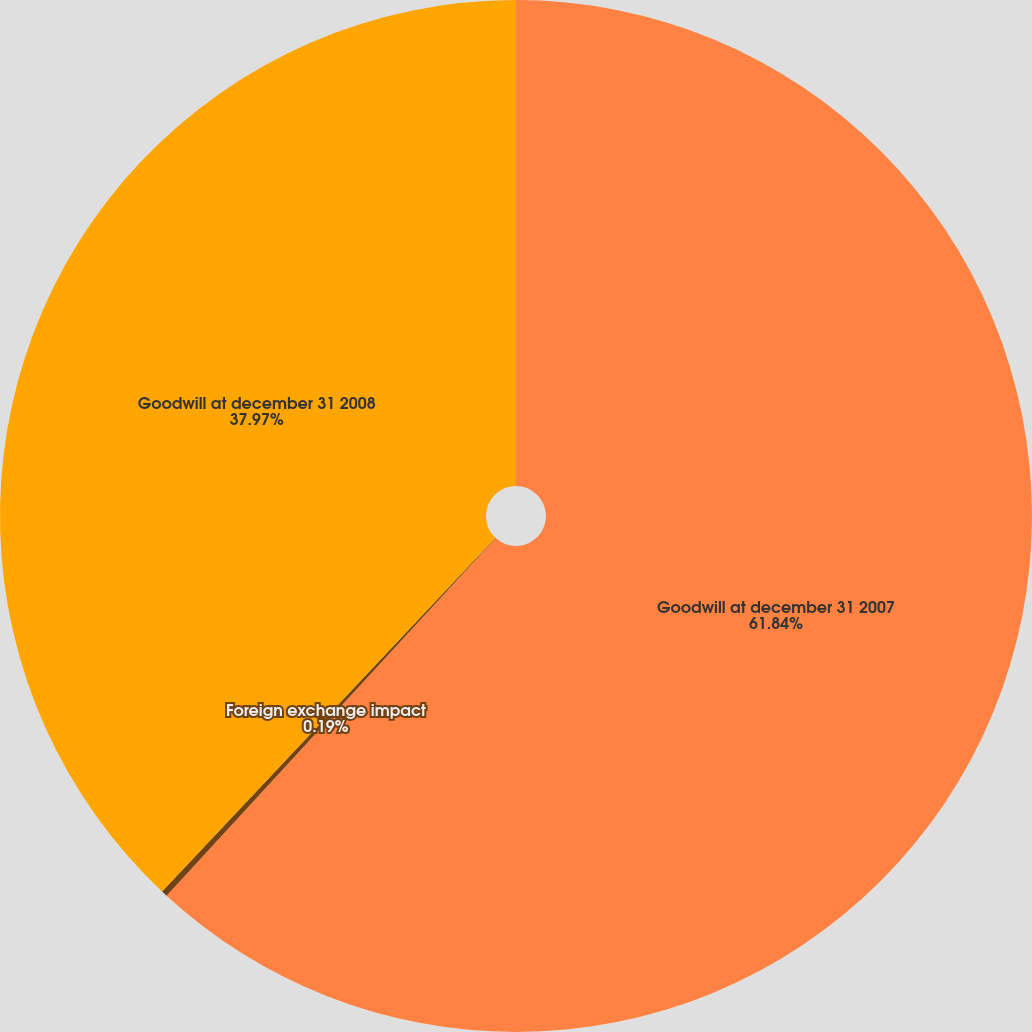Convert chart. <chart><loc_0><loc_0><loc_500><loc_500><pie_chart><fcel>Goodwill at december 31 2007<fcel>Foreign exchange impact<fcel>Goodwill at december 31 2008<nl><fcel>61.84%<fcel>0.19%<fcel>37.97%<nl></chart> 